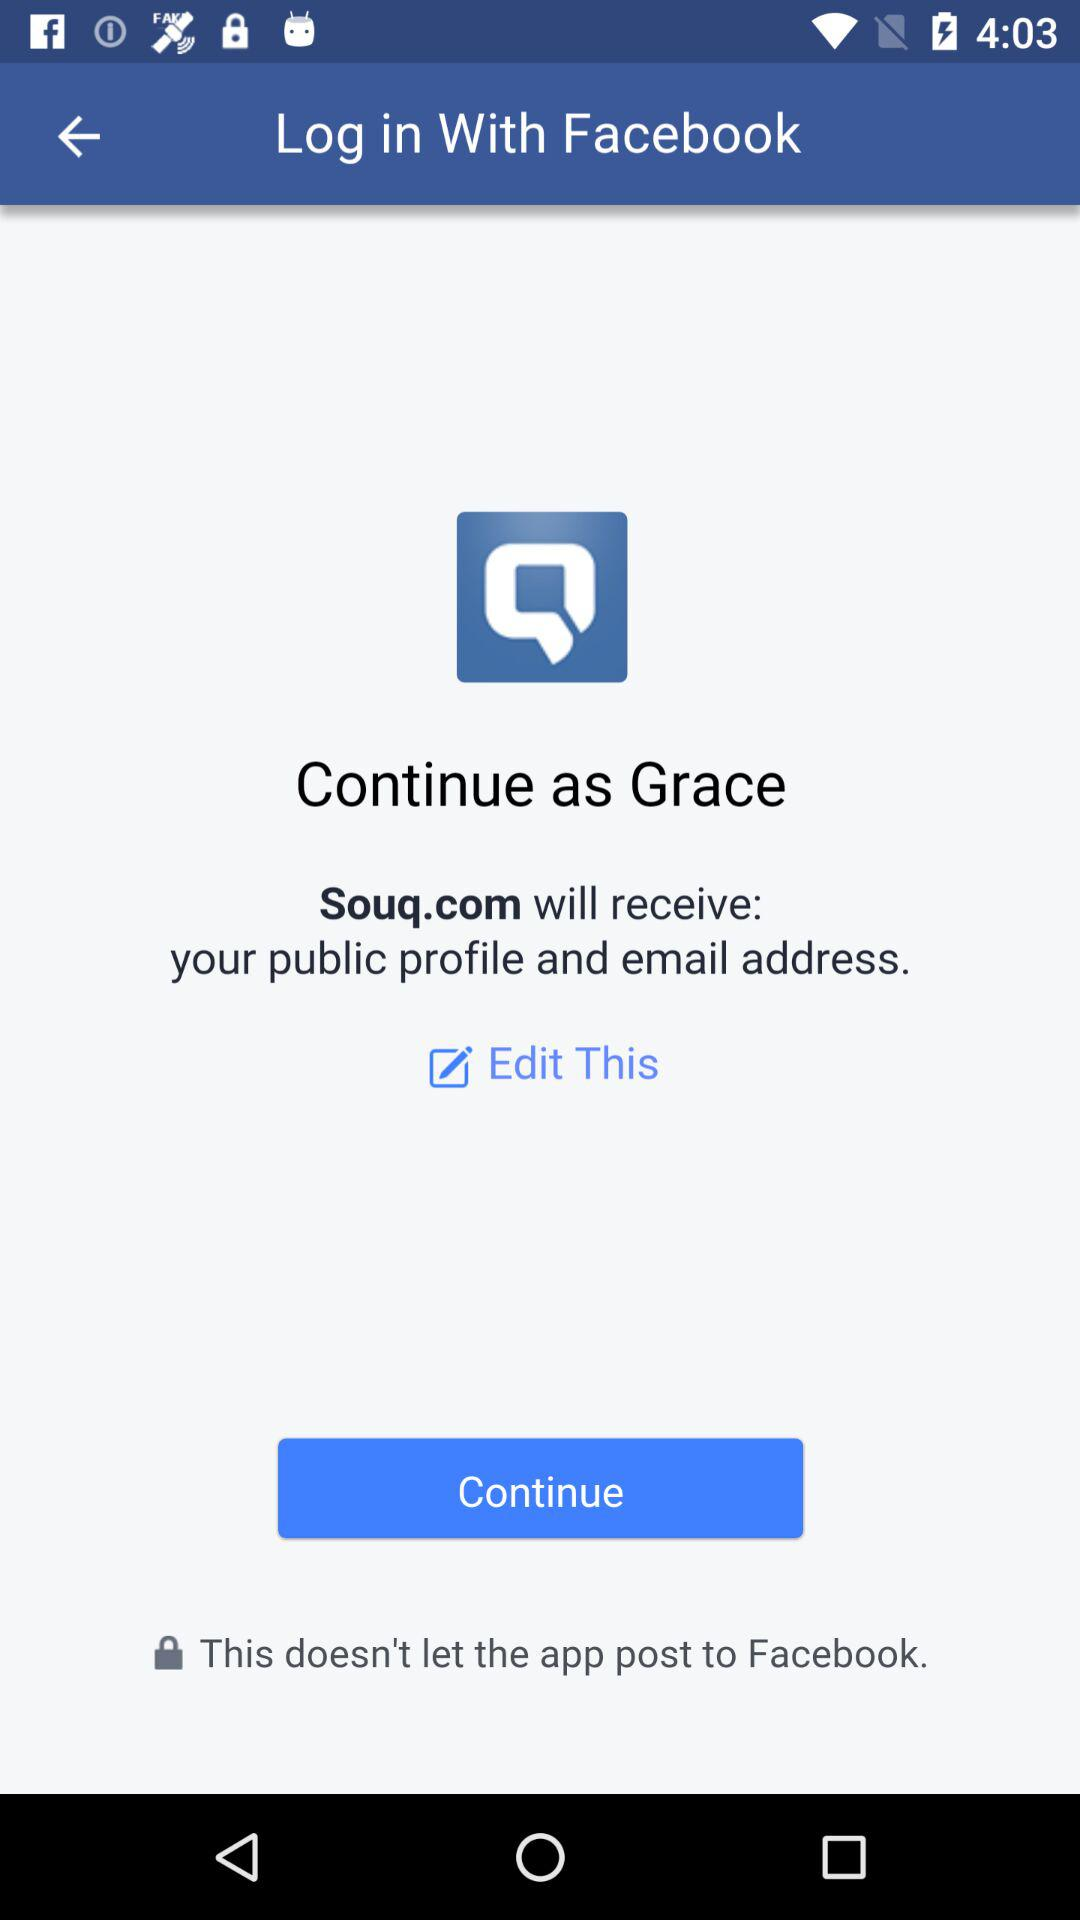Through what application can a user log in with? A user can log in with "Facebook". 